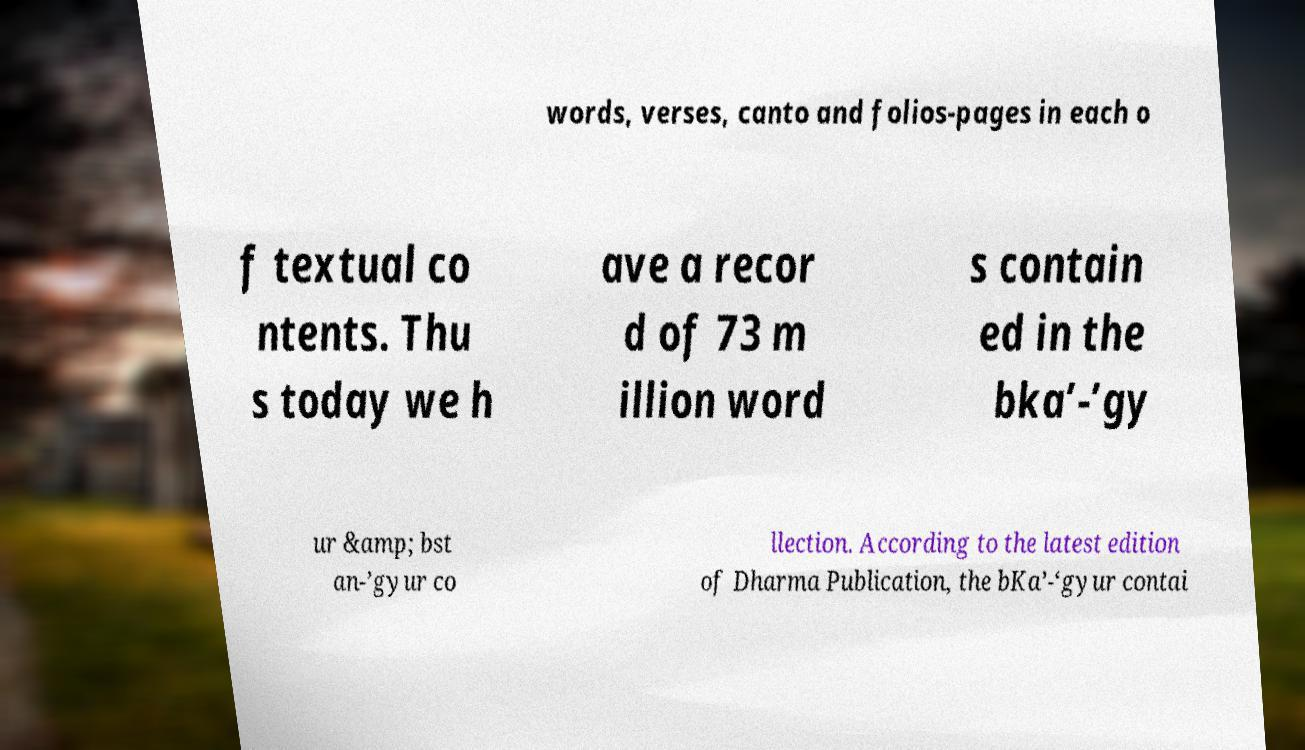What messages or text are displayed in this image? I need them in a readable, typed format. words, verses, canto and folios-pages in each o f textual co ntents. Thu s today we h ave a recor d of 73 m illion word s contain ed in the bka’-’gy ur &amp; bst an-’gyur co llection. According to the latest edition of Dharma Publication, the bKa’-‘gyur contai 